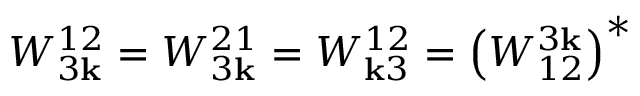<formula> <loc_0><loc_0><loc_500><loc_500>W _ { 3 { k } } ^ { 1 2 } = W _ { 3 { k } } ^ { 2 1 } = W _ { { k } 3 } ^ { 1 2 } = \left ( W _ { 1 2 } ^ { 3 { k } } \right ) ^ { * }</formula> 